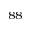Convert formula to latex. <formula><loc_0><loc_0><loc_500><loc_500>^ { 8 8 }</formula> 